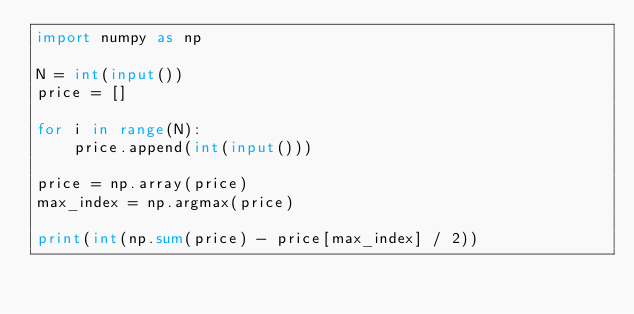Convert code to text. <code><loc_0><loc_0><loc_500><loc_500><_Python_>import numpy as np

N = int(input())
price = []

for i in range(N):
    price.append(int(input()))

price = np.array(price)
max_index = np.argmax(price)

print(int(np.sum(price) - price[max_index] / 2))</code> 